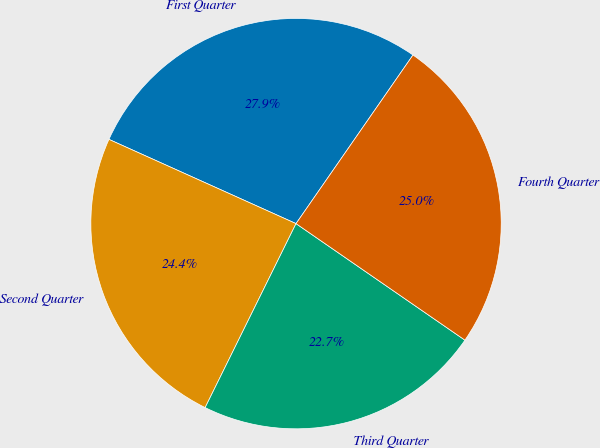<chart> <loc_0><loc_0><loc_500><loc_500><pie_chart><fcel>First Quarter<fcel>Second Quarter<fcel>Third Quarter<fcel>Fourth Quarter<nl><fcel>27.92%<fcel>24.43%<fcel>22.69%<fcel>24.96%<nl></chart> 